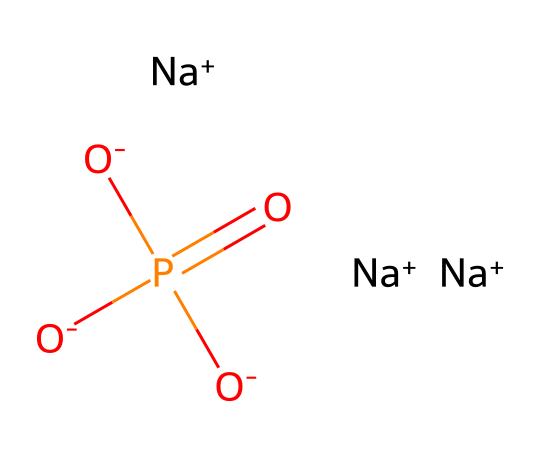What is the common name of this compound? The SMILES represents trisodium phosphate, a well-known cleaning agent, indicated by the presence of three sodium ions and a phosphate group.
Answer: trisodium phosphate How many sodium atoms are in the structure? The SMILES notation shows three sodium ions ([Na+]), which confirms there are three sodium atoms present in the compound.
Answer: three What is the oxidation state of phosphorus in this compound? The phosphorus atom is connected to four oxygen atoms within the phosphate group, and its overall charge can be deduced from its bonding and structure, leading to a +5 oxidation state.
Answer: +5 How many negatively charged oxygen atoms are present in this compound? The SMILES indicates three negatively charged oxygen atoms ([O-]) attached to the phosphorus, which is typical for phosphate ions.
Answer: three What role does this compound play in household cleaning? Trisodium phosphate serves as a cleaning agent due to its ability to act as a strong alkaline compound, which helps to remove grease and dirt.
Answer: cleaning agent Is this compound soluble in water? Trisodium phosphate is known to be soluble in water due to its ionic nature and the presence of sodium ions, which allows it to dissociate effectively in solution.
Answer: yes What type of compound is trisodium phosphate? Based on its structure and composition, trisodium phosphate is classified as a salt, specifically an inorganic salt formed from sodium and phosphate ions.
Answer: salt 